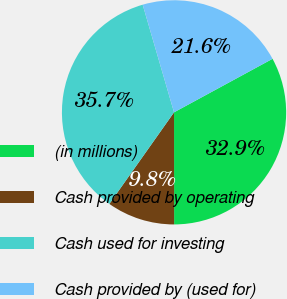Convert chart. <chart><loc_0><loc_0><loc_500><loc_500><pie_chart><fcel>(in millions)<fcel>Cash provided by operating<fcel>Cash used for investing<fcel>Cash provided by (used for)<nl><fcel>32.91%<fcel>9.8%<fcel>35.7%<fcel>21.59%<nl></chart> 